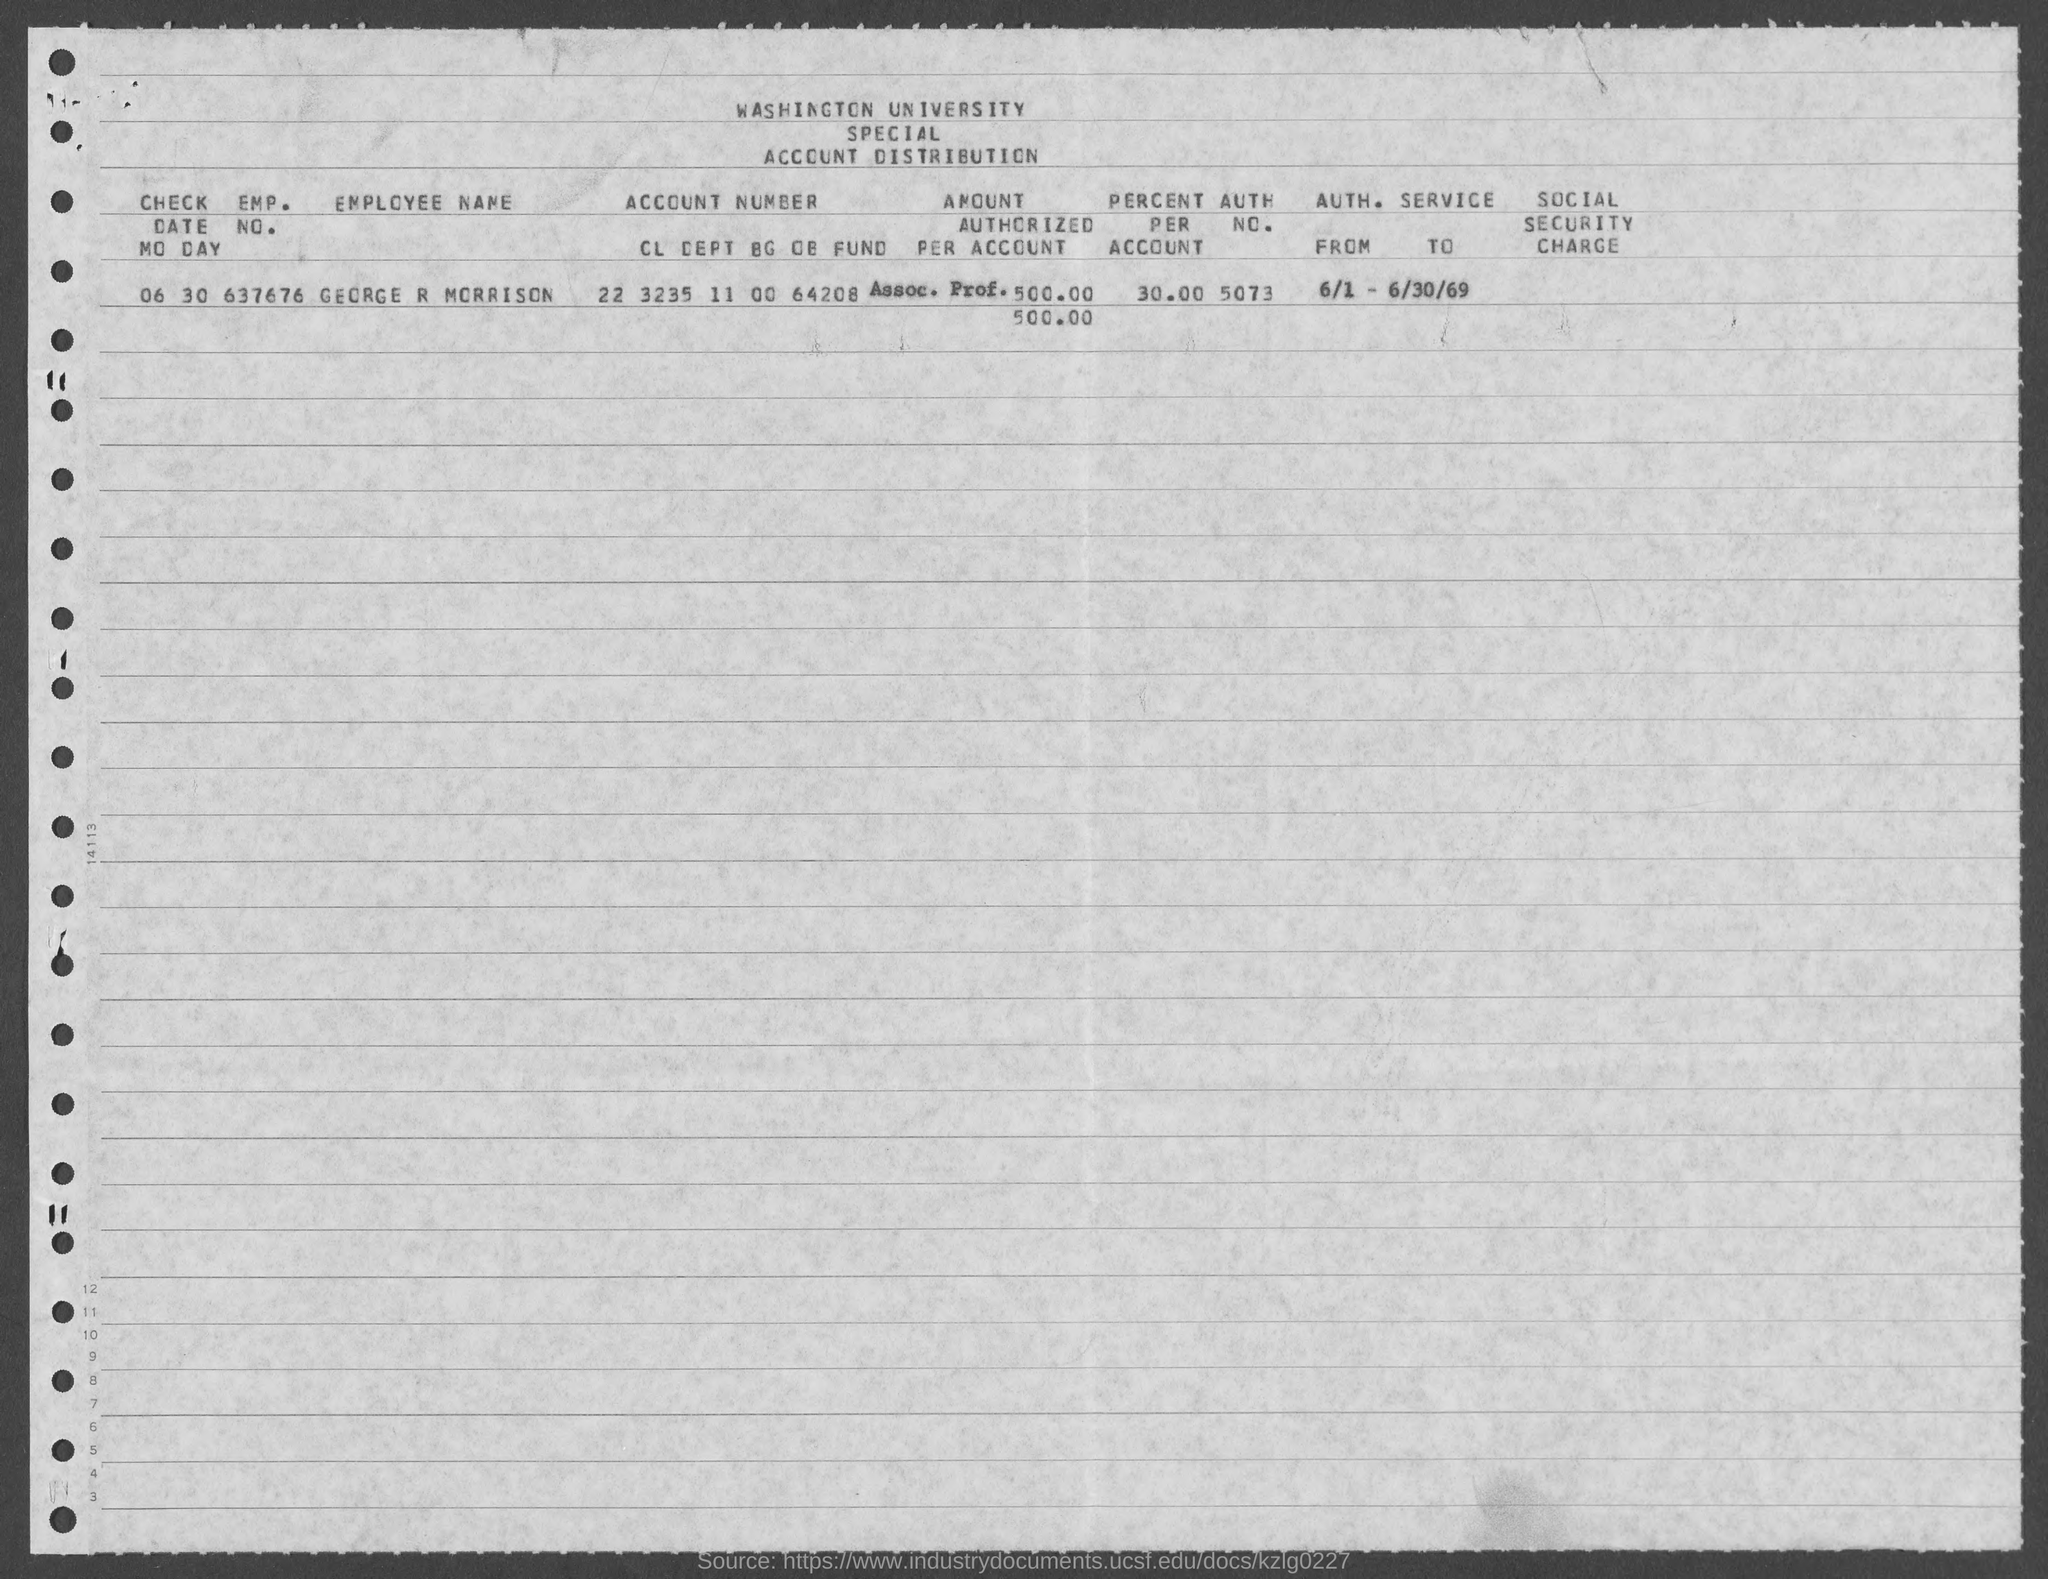List a handful of essential elements in this visual. The EMP. NO. of GEORGE R MORRISON is 637676. The employee name mentioned in the document is George R Morrison. The account distribution of a university is provided in the given information. The university in question is Washington. The AUTH. NO. of GEORGE R MORRISON, as listed in the document, is 5073. The percent per account of GEORGE R MORRISON is 30.00. 